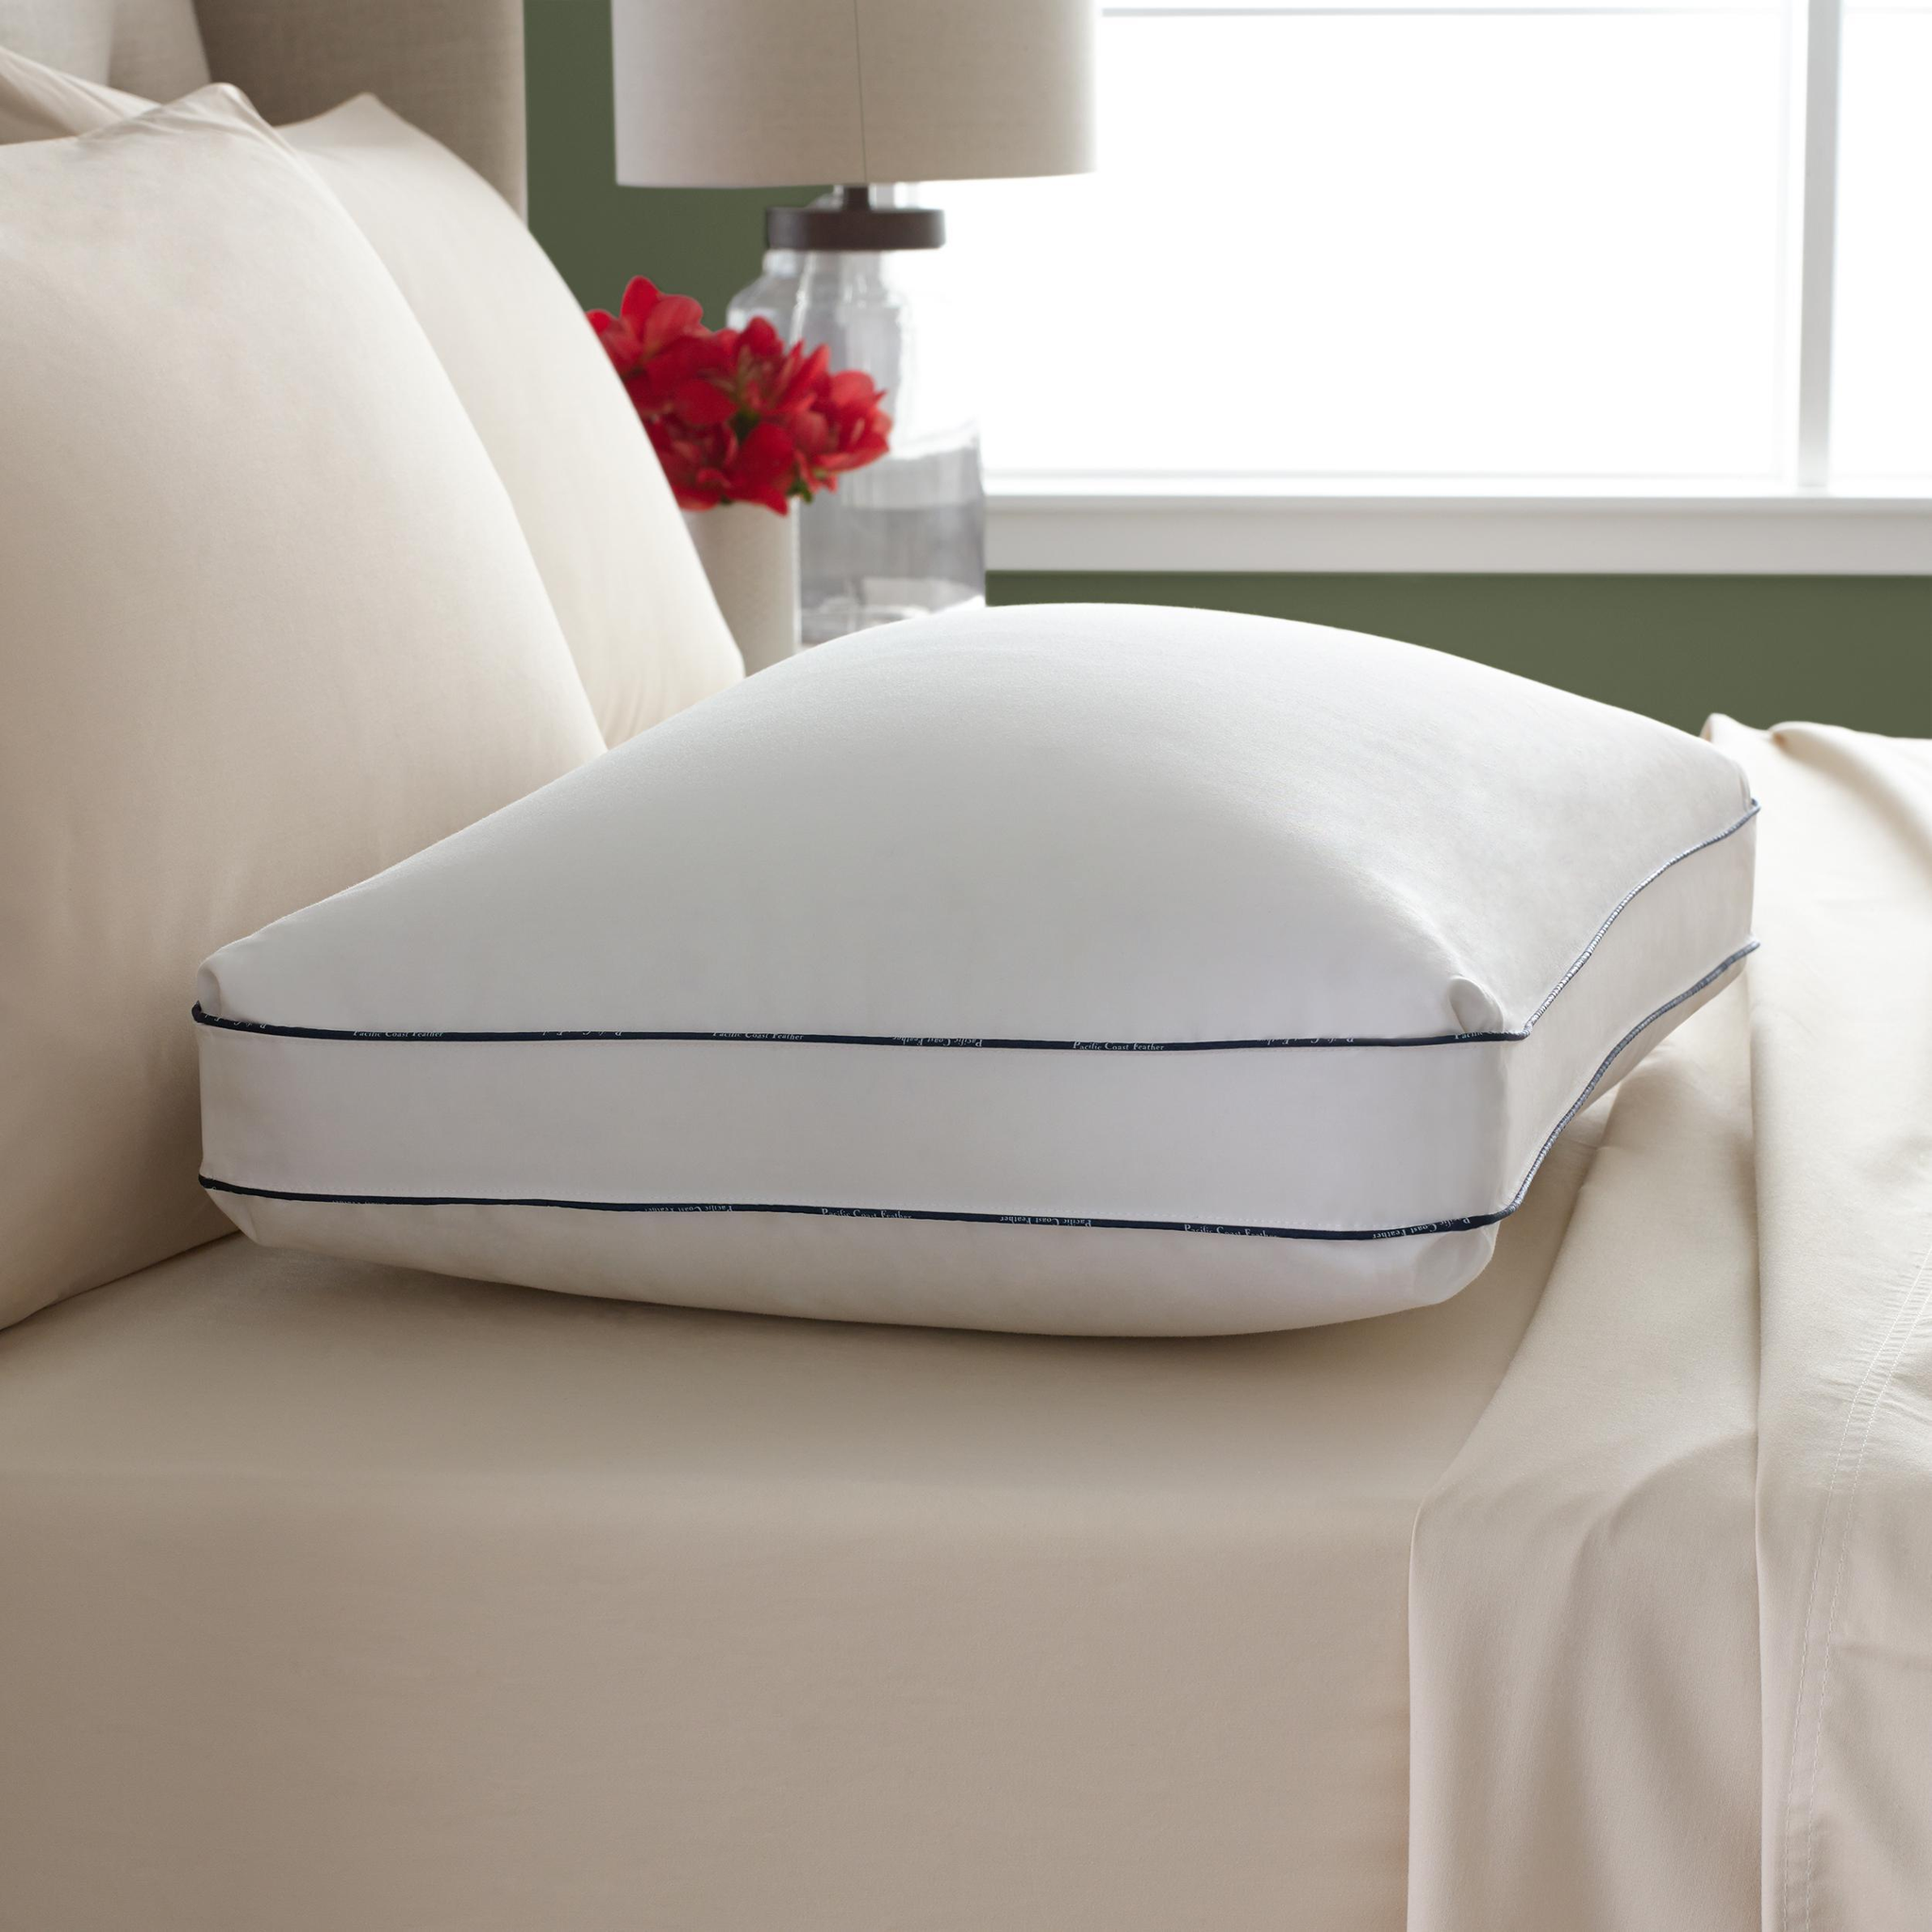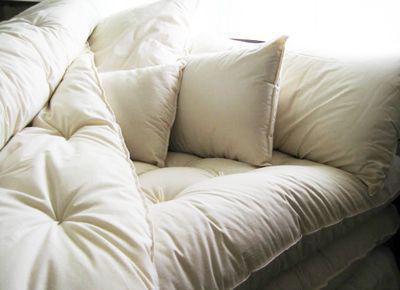The first image is the image on the left, the second image is the image on the right. Assess this claim about the two images: "There is a lamp visible in at least one image.". Correct or not? Answer yes or no. Yes. 